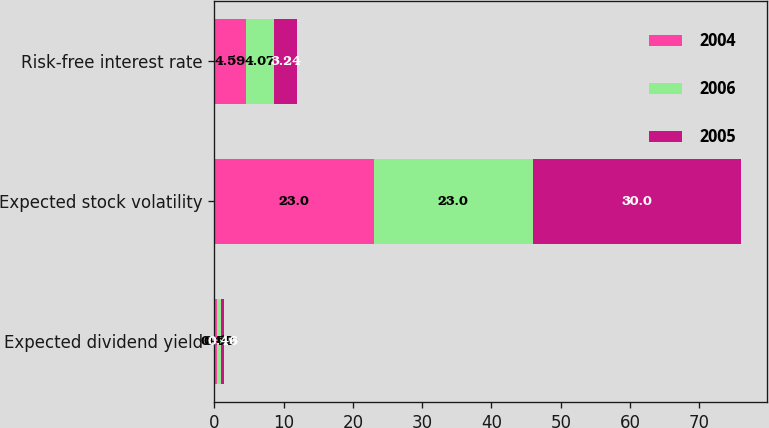<chart> <loc_0><loc_0><loc_500><loc_500><stacked_bar_chart><ecel><fcel>Expected dividend yield<fcel>Expected stock volatility<fcel>Risk-free interest rate<nl><fcel>2004<fcel>0.44<fcel>23<fcel>4.59<nl><fcel>2006<fcel>0.52<fcel>23<fcel>4.07<nl><fcel>2005<fcel>0.46<fcel>30<fcel>3.24<nl></chart> 